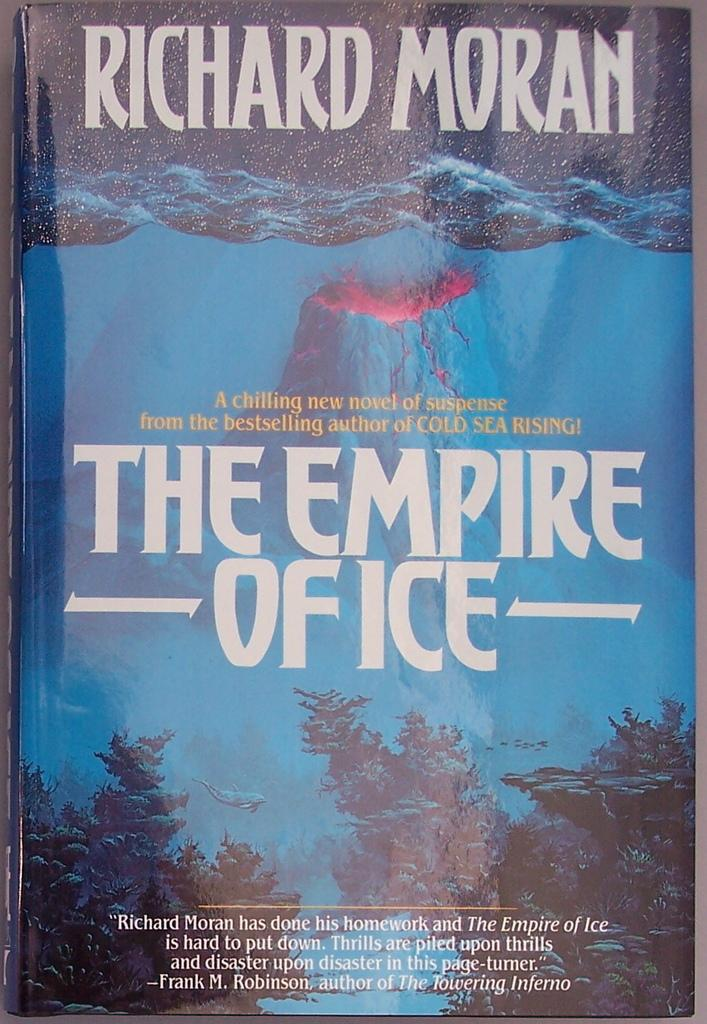<image>
Render a clear and concise summary of the photo. A book called The Empire Office written by Richard Moran. 